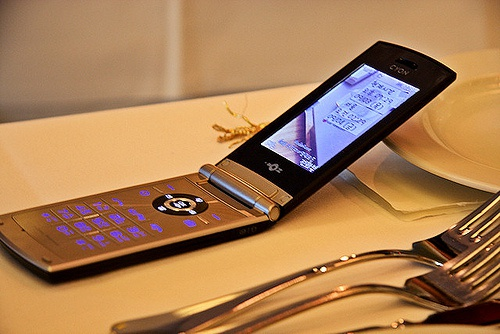Describe the objects in this image and their specific colors. I can see dining table in maroon, orange, brown, and black tones, cell phone in maroon, black, brown, and lightblue tones, dining table in maroon and tan tones, fork in maroon, brown, black, and orange tones, and fork in maroon, brown, and black tones in this image. 